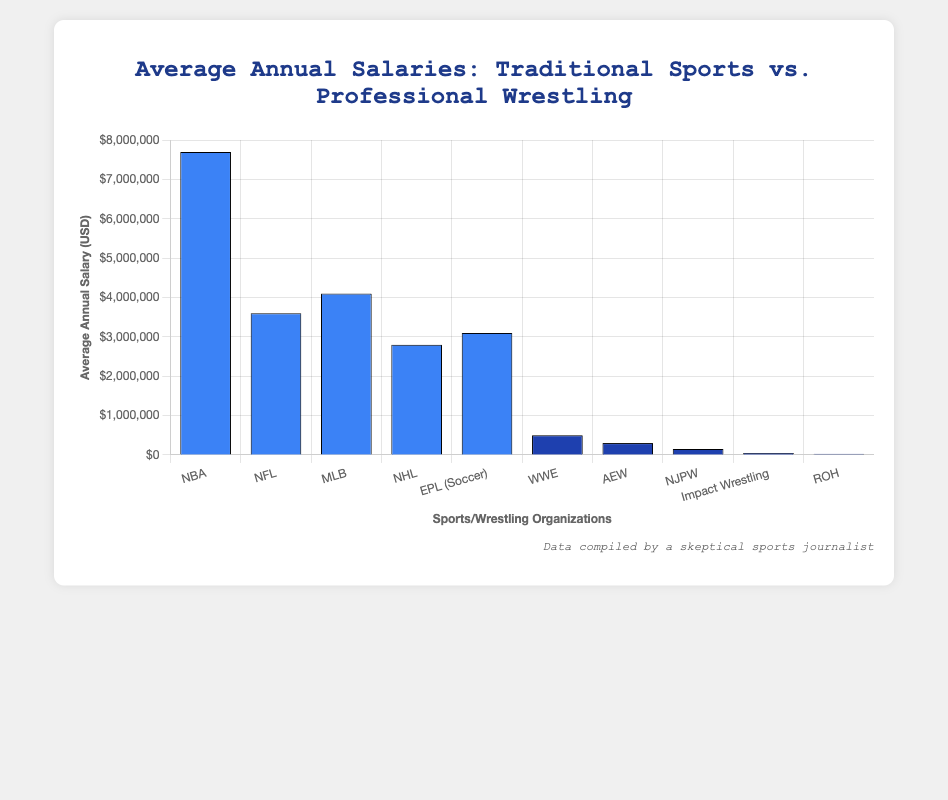Which traditional sport has the highest average annual salary? To find the traditional sport with the highest salary, look at the tallest blue bars among the traditional sports categories (NBA, NFL, MLB, NHL, EPL). The NBA has the highest bar among these.
Answer: NBA Which professional wrestling organization has the highest average annual salary? To identify the highest average salary among the wrestling organizations, look for the tallest dark blue bar. The WWE has the tallest dark blue bar.
Answer: WWE What is the difference in average annual salary between the NBA and WWE? The NBA has an average annual salary of $7,700,000 and the WWE has $500,000. Subtract the WWE salary from the NBA salary: 7,700,000 - 500,000 = 7,200,000.
Answer: 7,200,000 How do the average salaries of AEW and Impact Wrestling compare? To compare the salaries, look at the heights of the dark blue bars for AEW and Impact Wrestling. AEW's bar is taller than Impact Wrestling’s bar.
Answer: AEW has a higher salary than Impact Wrestling What is the combined average annual salary for NFL and NHL athletes? The NFL athletes have an average annual salary of $3,600,000 and the NHL athletes have $2,800,000. Add these two amounts together: 3,600,000 + 2,800,000 = 6,400,000.
Answer: 6,400,000 Which sport or organization has the lowest average annual salary? To find the lowest salary, look for the shortest bar on the chart. The shortest bar belongs to ROH in professional wrestling.
Answer: ROH How does the average annual salary of MLB compare to that of EPL (Soccer)? Compare the heights of the two blue bars for MLB and EPL. The MLB bar is slightly taller than the EPL bar, indicating a higher average salary.
Answer: MLB has a higher salary than EPL What is the average of the salaries of NBA, NFL, and MLB? First, sum the salaries: 7,700,000 (NBA) + 3,600,000 (NFL) + 4,100,000 (MLB) = 15,400,000. Divide by the number of sports: 15,400,000 / 3 = 5,133,333.33.
Answer: 5,133,333.33 By what factor is the average annual salary of NBA athletes higher than AEW wrestlers? The NBA salary is $7,700,000, and AEW is $300,000. Divide the NBA salary by the AEW salary: 7,700,000 / 300,000 ≈ 25.67.
Answer: 25.67 